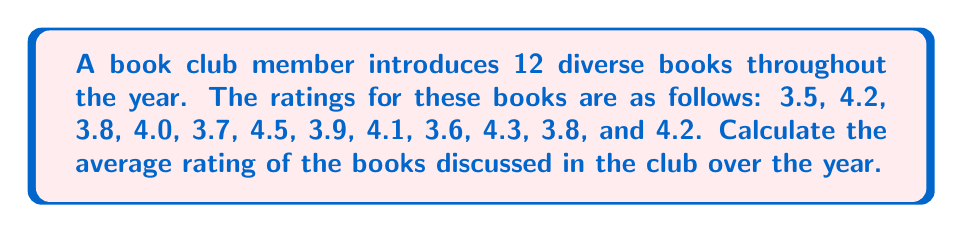Help me with this question. To find the average rating, we need to:

1. Sum up all the ratings
2. Divide the sum by the total number of books

Step 1: Calculate the sum of all ratings
$$3.5 + 4.2 + 3.8 + 4.0 + 3.7 + 4.5 + 3.9 + 4.1 + 3.6 + 4.3 + 3.8 + 4.2 = 47.6$$

Step 2: Count the total number of books
There are 12 books in total.

Step 3: Calculate the average by dividing the sum by the number of books
$$\text{Average} = \frac{\text{Sum of ratings}}{\text{Number of books}} = \frac{47.6}{12} = 3.9666...$$

Step 4: Round the result to two decimal places
$$3.97$$
Answer: $3.97$ 